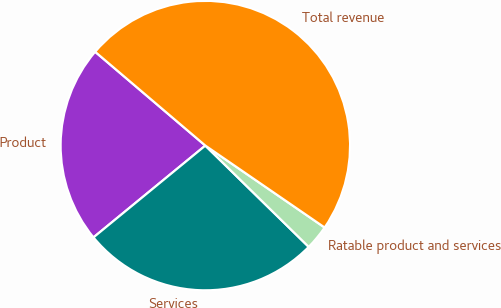Convert chart. <chart><loc_0><loc_0><loc_500><loc_500><pie_chart><fcel>Product<fcel>Services<fcel>Ratable product and services<fcel>Total revenue<nl><fcel>22.16%<fcel>26.72%<fcel>2.76%<fcel>48.35%<nl></chart> 